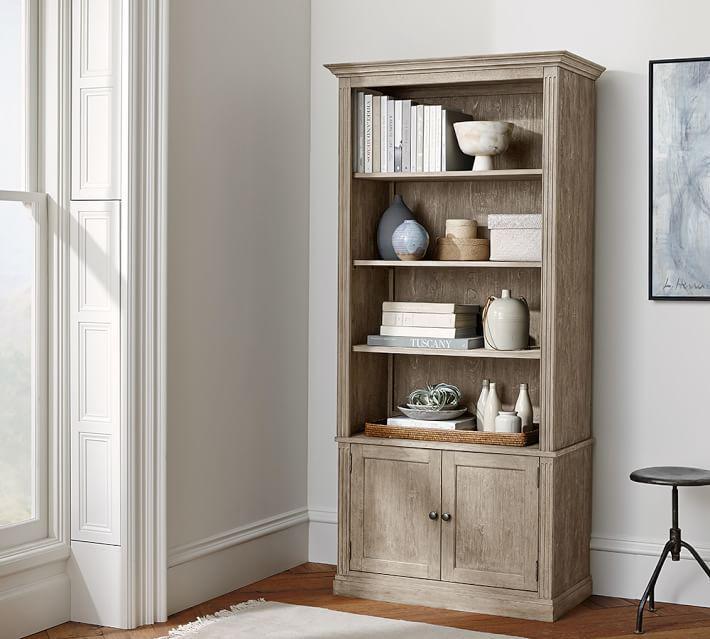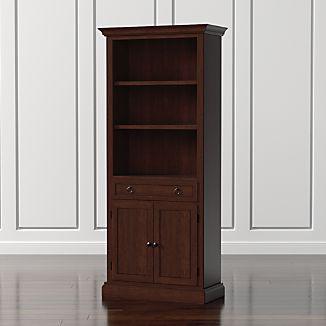The first image is the image on the left, the second image is the image on the right. For the images displayed, is the sentence "At least one tall, narrow bookcase has closed double doors at the bottom." factually correct? Answer yes or no. Yes. 